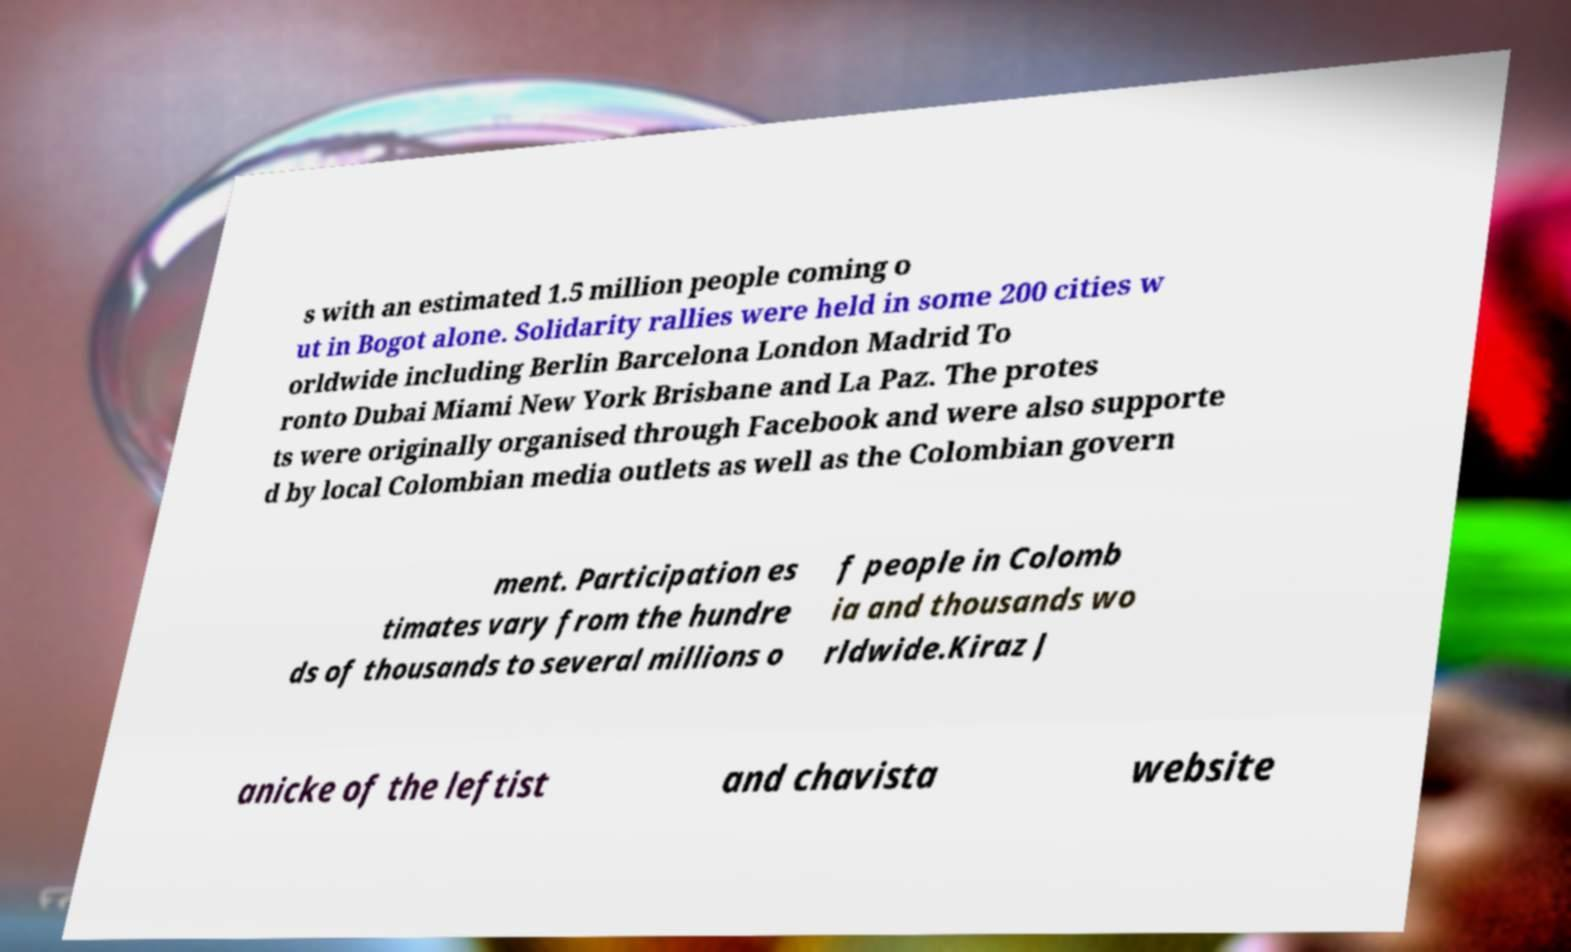For documentation purposes, I need the text within this image transcribed. Could you provide that? s with an estimated 1.5 million people coming o ut in Bogot alone. Solidarity rallies were held in some 200 cities w orldwide including Berlin Barcelona London Madrid To ronto Dubai Miami New York Brisbane and La Paz. The protes ts were originally organised through Facebook and were also supporte d by local Colombian media outlets as well as the Colombian govern ment. Participation es timates vary from the hundre ds of thousands to several millions o f people in Colomb ia and thousands wo rldwide.Kiraz J anicke of the leftist and chavista website 